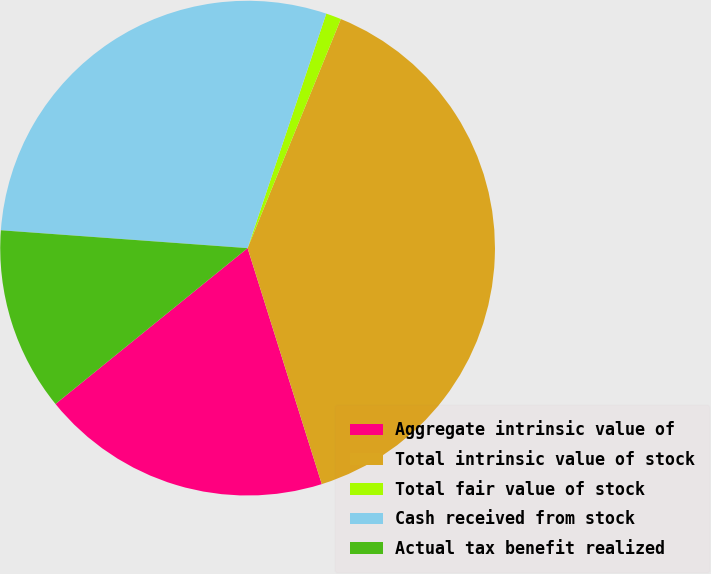<chart> <loc_0><loc_0><loc_500><loc_500><pie_chart><fcel>Aggregate intrinsic value of<fcel>Total intrinsic value of stock<fcel>Total fair value of stock<fcel>Cash received from stock<fcel>Actual tax benefit realized<nl><fcel>19.0%<fcel>39.0%<fcel>1.0%<fcel>29.0%<fcel>12.0%<nl></chart> 